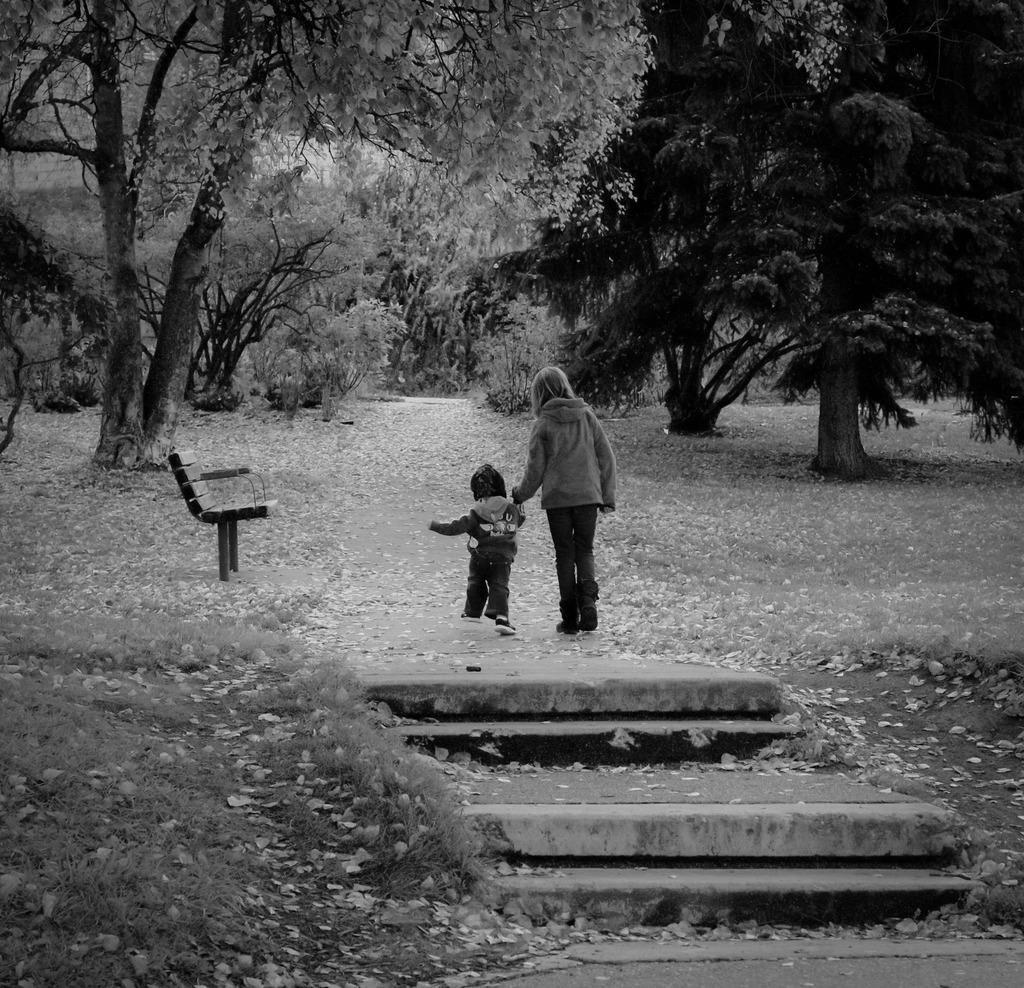Who is present in the image? There is a woman and a child in the image. What are the woman and child doing in the image? The woman and child are walking through a park. What can be seen in the park? There is a bench and a lot of trees in the image. What type of juice is the child drinking from a spoon in the image? There is no juice or spoon present in the image; the child is walking with the woman through a park. 